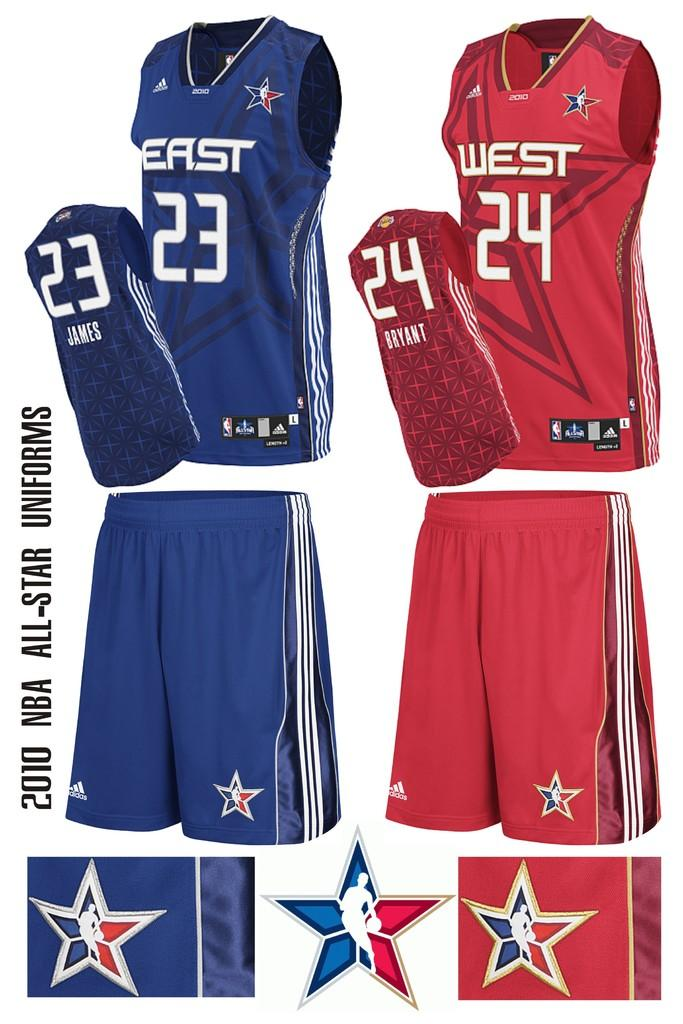Provide a one-sentence caption for the provided image. A display of two different sports uniforms with one saying EAST and one saying WEST on the front. 